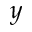Convert formula to latex. <formula><loc_0><loc_0><loc_500><loc_500>y</formula> 